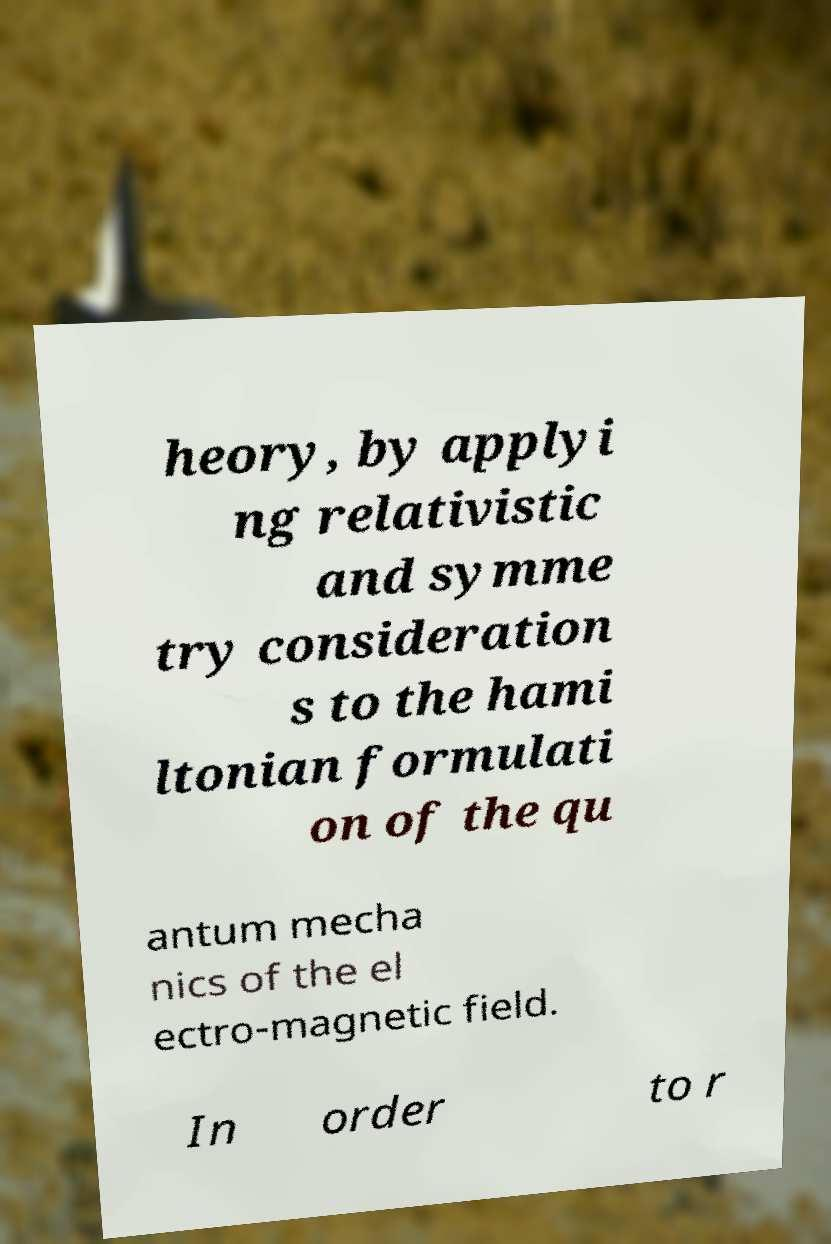Can you read and provide the text displayed in the image?This photo seems to have some interesting text. Can you extract and type it out for me? heory, by applyi ng relativistic and symme try consideration s to the hami ltonian formulati on of the qu antum mecha nics of the el ectro-magnetic field. In order to r 